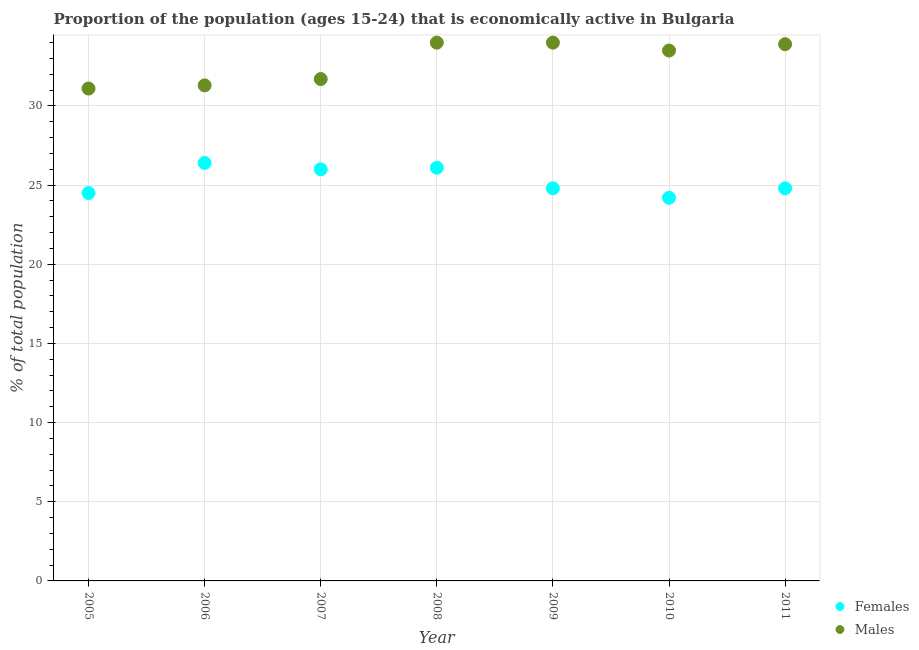How many different coloured dotlines are there?
Keep it short and to the point. 2. Is the number of dotlines equal to the number of legend labels?
Offer a terse response. Yes. What is the percentage of economically active male population in 2011?
Make the answer very short. 33.9. Across all years, what is the maximum percentage of economically active female population?
Ensure brevity in your answer.  26.4. Across all years, what is the minimum percentage of economically active male population?
Offer a terse response. 31.1. In which year was the percentage of economically active female population minimum?
Your answer should be very brief. 2010. What is the total percentage of economically active male population in the graph?
Your answer should be very brief. 229.5. What is the difference between the percentage of economically active male population in 2009 and that in 2011?
Provide a succinct answer. 0.1. What is the difference between the percentage of economically active male population in 2007 and the percentage of economically active female population in 2010?
Your answer should be very brief. 7.5. What is the average percentage of economically active male population per year?
Offer a very short reply. 32.79. In the year 2010, what is the difference between the percentage of economically active female population and percentage of economically active male population?
Offer a terse response. -9.3. What is the ratio of the percentage of economically active female population in 2006 to that in 2007?
Your answer should be compact. 1.02. Is the percentage of economically active female population in 2010 less than that in 2011?
Keep it short and to the point. Yes. Is the difference between the percentage of economically active male population in 2005 and 2011 greater than the difference between the percentage of economically active female population in 2005 and 2011?
Give a very brief answer. No. What is the difference between the highest and the second highest percentage of economically active female population?
Provide a succinct answer. 0.3. What is the difference between the highest and the lowest percentage of economically active female population?
Give a very brief answer. 2.2. Is the percentage of economically active female population strictly greater than the percentage of economically active male population over the years?
Offer a very short reply. No. How many dotlines are there?
Provide a succinct answer. 2. Are the values on the major ticks of Y-axis written in scientific E-notation?
Give a very brief answer. No. How are the legend labels stacked?
Provide a succinct answer. Vertical. What is the title of the graph?
Your answer should be very brief. Proportion of the population (ages 15-24) that is economically active in Bulgaria. Does "Investment in Transport" appear as one of the legend labels in the graph?
Offer a very short reply. No. What is the label or title of the Y-axis?
Give a very brief answer. % of total population. What is the % of total population in Females in 2005?
Keep it short and to the point. 24.5. What is the % of total population in Males in 2005?
Make the answer very short. 31.1. What is the % of total population of Females in 2006?
Your response must be concise. 26.4. What is the % of total population of Males in 2006?
Offer a very short reply. 31.3. What is the % of total population in Males in 2007?
Your response must be concise. 31.7. What is the % of total population of Females in 2008?
Offer a very short reply. 26.1. What is the % of total population of Males in 2008?
Provide a short and direct response. 34. What is the % of total population in Females in 2009?
Provide a short and direct response. 24.8. What is the % of total population in Females in 2010?
Provide a short and direct response. 24.2. What is the % of total population in Males in 2010?
Keep it short and to the point. 33.5. What is the % of total population of Females in 2011?
Make the answer very short. 24.8. What is the % of total population of Males in 2011?
Offer a terse response. 33.9. Across all years, what is the maximum % of total population of Females?
Your answer should be compact. 26.4. Across all years, what is the maximum % of total population of Males?
Give a very brief answer. 34. Across all years, what is the minimum % of total population in Females?
Give a very brief answer. 24.2. Across all years, what is the minimum % of total population in Males?
Ensure brevity in your answer.  31.1. What is the total % of total population in Females in the graph?
Provide a succinct answer. 176.8. What is the total % of total population of Males in the graph?
Your answer should be very brief. 229.5. What is the difference between the % of total population in Females in 2005 and that in 2007?
Make the answer very short. -1.5. What is the difference between the % of total population of Males in 2005 and that in 2007?
Your answer should be very brief. -0.6. What is the difference between the % of total population of Females in 2005 and that in 2008?
Your answer should be compact. -1.6. What is the difference between the % of total population of Males in 2005 and that in 2008?
Give a very brief answer. -2.9. What is the difference between the % of total population of Males in 2005 and that in 2009?
Keep it short and to the point. -2.9. What is the difference between the % of total population of Males in 2005 and that in 2010?
Make the answer very short. -2.4. What is the difference between the % of total population in Males in 2006 and that in 2007?
Ensure brevity in your answer.  -0.4. What is the difference between the % of total population of Females in 2006 and that in 2008?
Offer a terse response. 0.3. What is the difference between the % of total population in Females in 2006 and that in 2009?
Offer a terse response. 1.6. What is the difference between the % of total population of Males in 2006 and that in 2009?
Your answer should be compact. -2.7. What is the difference between the % of total population of Males in 2006 and that in 2010?
Offer a very short reply. -2.2. What is the difference between the % of total population in Males in 2007 and that in 2008?
Make the answer very short. -2.3. What is the difference between the % of total population in Females in 2007 and that in 2009?
Provide a short and direct response. 1.2. What is the difference between the % of total population of Females in 2007 and that in 2010?
Your answer should be very brief. 1.8. What is the difference between the % of total population of Females in 2007 and that in 2011?
Offer a terse response. 1.2. What is the difference between the % of total population of Males in 2007 and that in 2011?
Provide a succinct answer. -2.2. What is the difference between the % of total population of Females in 2008 and that in 2009?
Your response must be concise. 1.3. What is the difference between the % of total population in Males in 2008 and that in 2009?
Ensure brevity in your answer.  0. What is the difference between the % of total population in Females in 2008 and that in 2010?
Your response must be concise. 1.9. What is the difference between the % of total population of Females in 2008 and that in 2011?
Your answer should be very brief. 1.3. What is the difference between the % of total population of Males in 2008 and that in 2011?
Provide a short and direct response. 0.1. What is the difference between the % of total population in Males in 2009 and that in 2010?
Offer a very short reply. 0.5. What is the difference between the % of total population of Males in 2009 and that in 2011?
Provide a succinct answer. 0.1. What is the difference between the % of total population in Females in 2010 and that in 2011?
Offer a terse response. -0.6. What is the difference between the % of total population in Females in 2005 and the % of total population in Males in 2007?
Provide a short and direct response. -7.2. What is the difference between the % of total population in Females in 2005 and the % of total population in Males in 2008?
Offer a very short reply. -9.5. What is the difference between the % of total population of Females in 2005 and the % of total population of Males in 2009?
Your response must be concise. -9.5. What is the difference between the % of total population of Females in 2005 and the % of total population of Males in 2011?
Provide a short and direct response. -9.4. What is the difference between the % of total population of Females in 2006 and the % of total population of Males in 2007?
Provide a succinct answer. -5.3. What is the difference between the % of total population of Females in 2006 and the % of total population of Males in 2008?
Your response must be concise. -7.6. What is the difference between the % of total population of Females in 2006 and the % of total population of Males in 2009?
Offer a very short reply. -7.6. What is the difference between the % of total population in Females in 2006 and the % of total population in Males in 2010?
Your answer should be compact. -7.1. What is the difference between the % of total population of Females in 2006 and the % of total population of Males in 2011?
Offer a terse response. -7.5. What is the difference between the % of total population in Females in 2007 and the % of total population in Males in 2008?
Provide a succinct answer. -8. What is the difference between the % of total population in Females in 2008 and the % of total population in Males in 2010?
Your response must be concise. -7.4. What is the difference between the % of total population of Females in 2008 and the % of total population of Males in 2011?
Offer a terse response. -7.8. What is the average % of total population in Females per year?
Provide a succinct answer. 25.26. What is the average % of total population in Males per year?
Provide a short and direct response. 32.79. In the year 2005, what is the difference between the % of total population in Females and % of total population in Males?
Offer a very short reply. -6.6. In the year 2009, what is the difference between the % of total population of Females and % of total population of Males?
Offer a terse response. -9.2. What is the ratio of the % of total population in Females in 2005 to that in 2006?
Offer a terse response. 0.93. What is the ratio of the % of total population in Females in 2005 to that in 2007?
Provide a succinct answer. 0.94. What is the ratio of the % of total population in Males in 2005 to that in 2007?
Your answer should be very brief. 0.98. What is the ratio of the % of total population in Females in 2005 to that in 2008?
Your response must be concise. 0.94. What is the ratio of the % of total population in Males in 2005 to that in 2008?
Your answer should be very brief. 0.91. What is the ratio of the % of total population in Females in 2005 to that in 2009?
Offer a very short reply. 0.99. What is the ratio of the % of total population in Males in 2005 to that in 2009?
Your answer should be very brief. 0.91. What is the ratio of the % of total population in Females in 2005 to that in 2010?
Your response must be concise. 1.01. What is the ratio of the % of total population in Males in 2005 to that in 2010?
Give a very brief answer. 0.93. What is the ratio of the % of total population in Females in 2005 to that in 2011?
Give a very brief answer. 0.99. What is the ratio of the % of total population in Males in 2005 to that in 2011?
Offer a very short reply. 0.92. What is the ratio of the % of total population of Females in 2006 to that in 2007?
Your answer should be very brief. 1.02. What is the ratio of the % of total population of Males in 2006 to that in 2007?
Offer a very short reply. 0.99. What is the ratio of the % of total population in Females in 2006 to that in 2008?
Your answer should be compact. 1.01. What is the ratio of the % of total population of Males in 2006 to that in 2008?
Your answer should be compact. 0.92. What is the ratio of the % of total population of Females in 2006 to that in 2009?
Ensure brevity in your answer.  1.06. What is the ratio of the % of total population of Males in 2006 to that in 2009?
Keep it short and to the point. 0.92. What is the ratio of the % of total population in Females in 2006 to that in 2010?
Offer a very short reply. 1.09. What is the ratio of the % of total population in Males in 2006 to that in 2010?
Your answer should be compact. 0.93. What is the ratio of the % of total population of Females in 2006 to that in 2011?
Provide a short and direct response. 1.06. What is the ratio of the % of total population in Males in 2006 to that in 2011?
Ensure brevity in your answer.  0.92. What is the ratio of the % of total population in Males in 2007 to that in 2008?
Your response must be concise. 0.93. What is the ratio of the % of total population in Females in 2007 to that in 2009?
Offer a terse response. 1.05. What is the ratio of the % of total population in Males in 2007 to that in 2009?
Keep it short and to the point. 0.93. What is the ratio of the % of total population of Females in 2007 to that in 2010?
Provide a succinct answer. 1.07. What is the ratio of the % of total population of Males in 2007 to that in 2010?
Keep it short and to the point. 0.95. What is the ratio of the % of total population of Females in 2007 to that in 2011?
Keep it short and to the point. 1.05. What is the ratio of the % of total population of Males in 2007 to that in 2011?
Provide a succinct answer. 0.94. What is the ratio of the % of total population in Females in 2008 to that in 2009?
Your response must be concise. 1.05. What is the ratio of the % of total population in Females in 2008 to that in 2010?
Provide a short and direct response. 1.08. What is the ratio of the % of total population in Males in 2008 to that in 2010?
Provide a succinct answer. 1.01. What is the ratio of the % of total population of Females in 2008 to that in 2011?
Provide a short and direct response. 1.05. What is the ratio of the % of total population of Males in 2008 to that in 2011?
Your response must be concise. 1. What is the ratio of the % of total population of Females in 2009 to that in 2010?
Your response must be concise. 1.02. What is the ratio of the % of total population in Males in 2009 to that in 2010?
Keep it short and to the point. 1.01. What is the ratio of the % of total population of Females in 2009 to that in 2011?
Offer a terse response. 1. What is the ratio of the % of total population in Males in 2009 to that in 2011?
Keep it short and to the point. 1. What is the ratio of the % of total population of Females in 2010 to that in 2011?
Ensure brevity in your answer.  0.98. What is the difference between the highest and the second highest % of total population in Females?
Offer a very short reply. 0.3. 